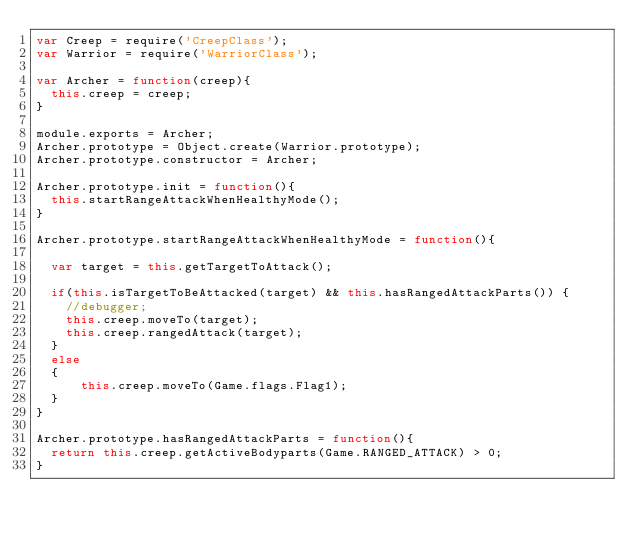<code> <loc_0><loc_0><loc_500><loc_500><_JavaScript_>var Creep = require('CreepClass');
var Warrior = require('WarriorClass');

var Archer = function(creep){
  this.creep = creep;
}

module.exports = Archer;
Archer.prototype = Object.create(Warrior.prototype);
Archer.prototype.constructor = Archer;
   
Archer.prototype.init = function(){
  this.startRangeAttackWhenHealthyMode();
}

Archer.prototype.startRangeAttackWhenHealthyMode = function(){
    
  var target = this.getTargetToAttack();

  if(this.isTargetToBeAttacked(target) && this.hasRangedAttackParts()) {
    //debugger;
    this.creep.moveTo(target);  
    this.creep.rangedAttack(target);
  }
  else
  {
      this.creep.moveTo(Game.flags.Flag1);       
  }
}

Archer.prototype.hasRangedAttackParts = function(){
  return this.creep.getActiveBodyparts(Game.RANGED_ATTACK) > 0;
}  
 </code> 